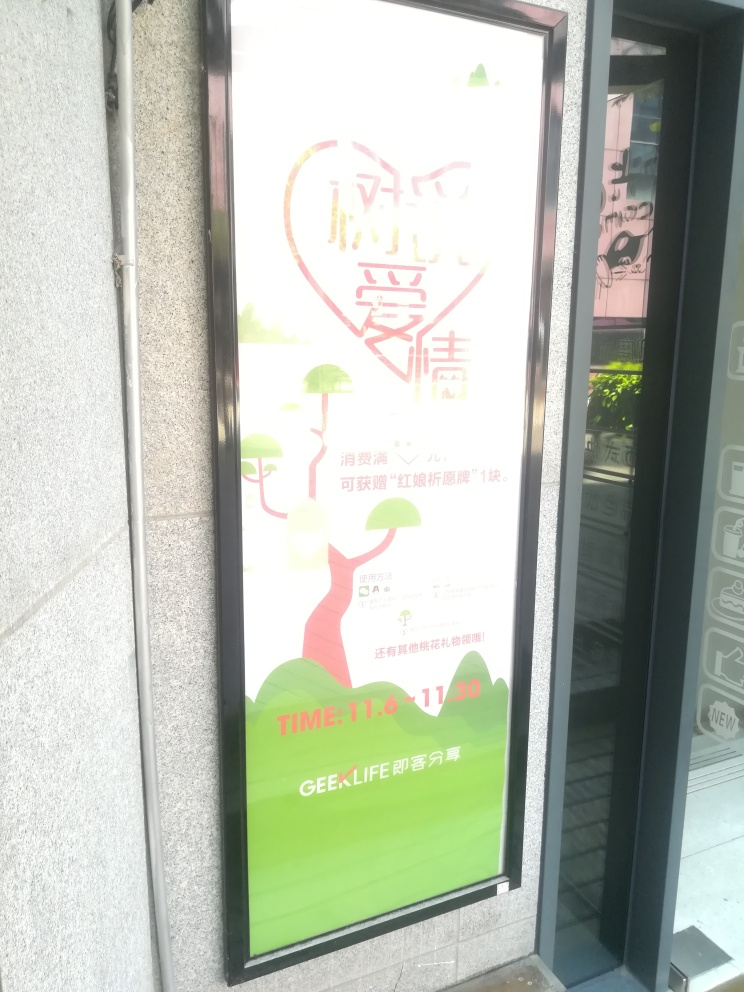What information is being advertised in this image? This image appears to be an advertisement for an event or a campaign. It features a heart and some trees, which might suggest themes of love or environmental friendliness. Specific details, such as event dates or locations, may be included but are not clearly visible due to the image's exposure and quality. 